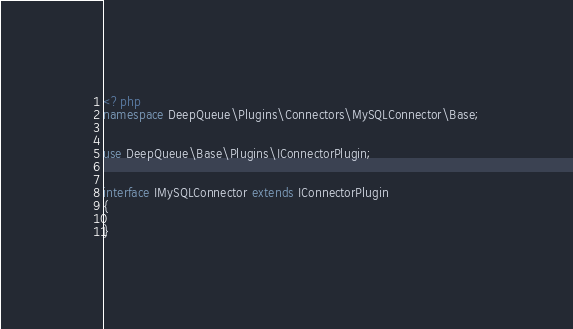Convert code to text. <code><loc_0><loc_0><loc_500><loc_500><_PHP_><?php
namespace DeepQueue\Plugins\Connectors\MySQLConnector\Base;


use DeepQueue\Base\Plugins\IConnectorPlugin;


interface IMySQLConnector extends IConnectorPlugin
{
	
}</code> 